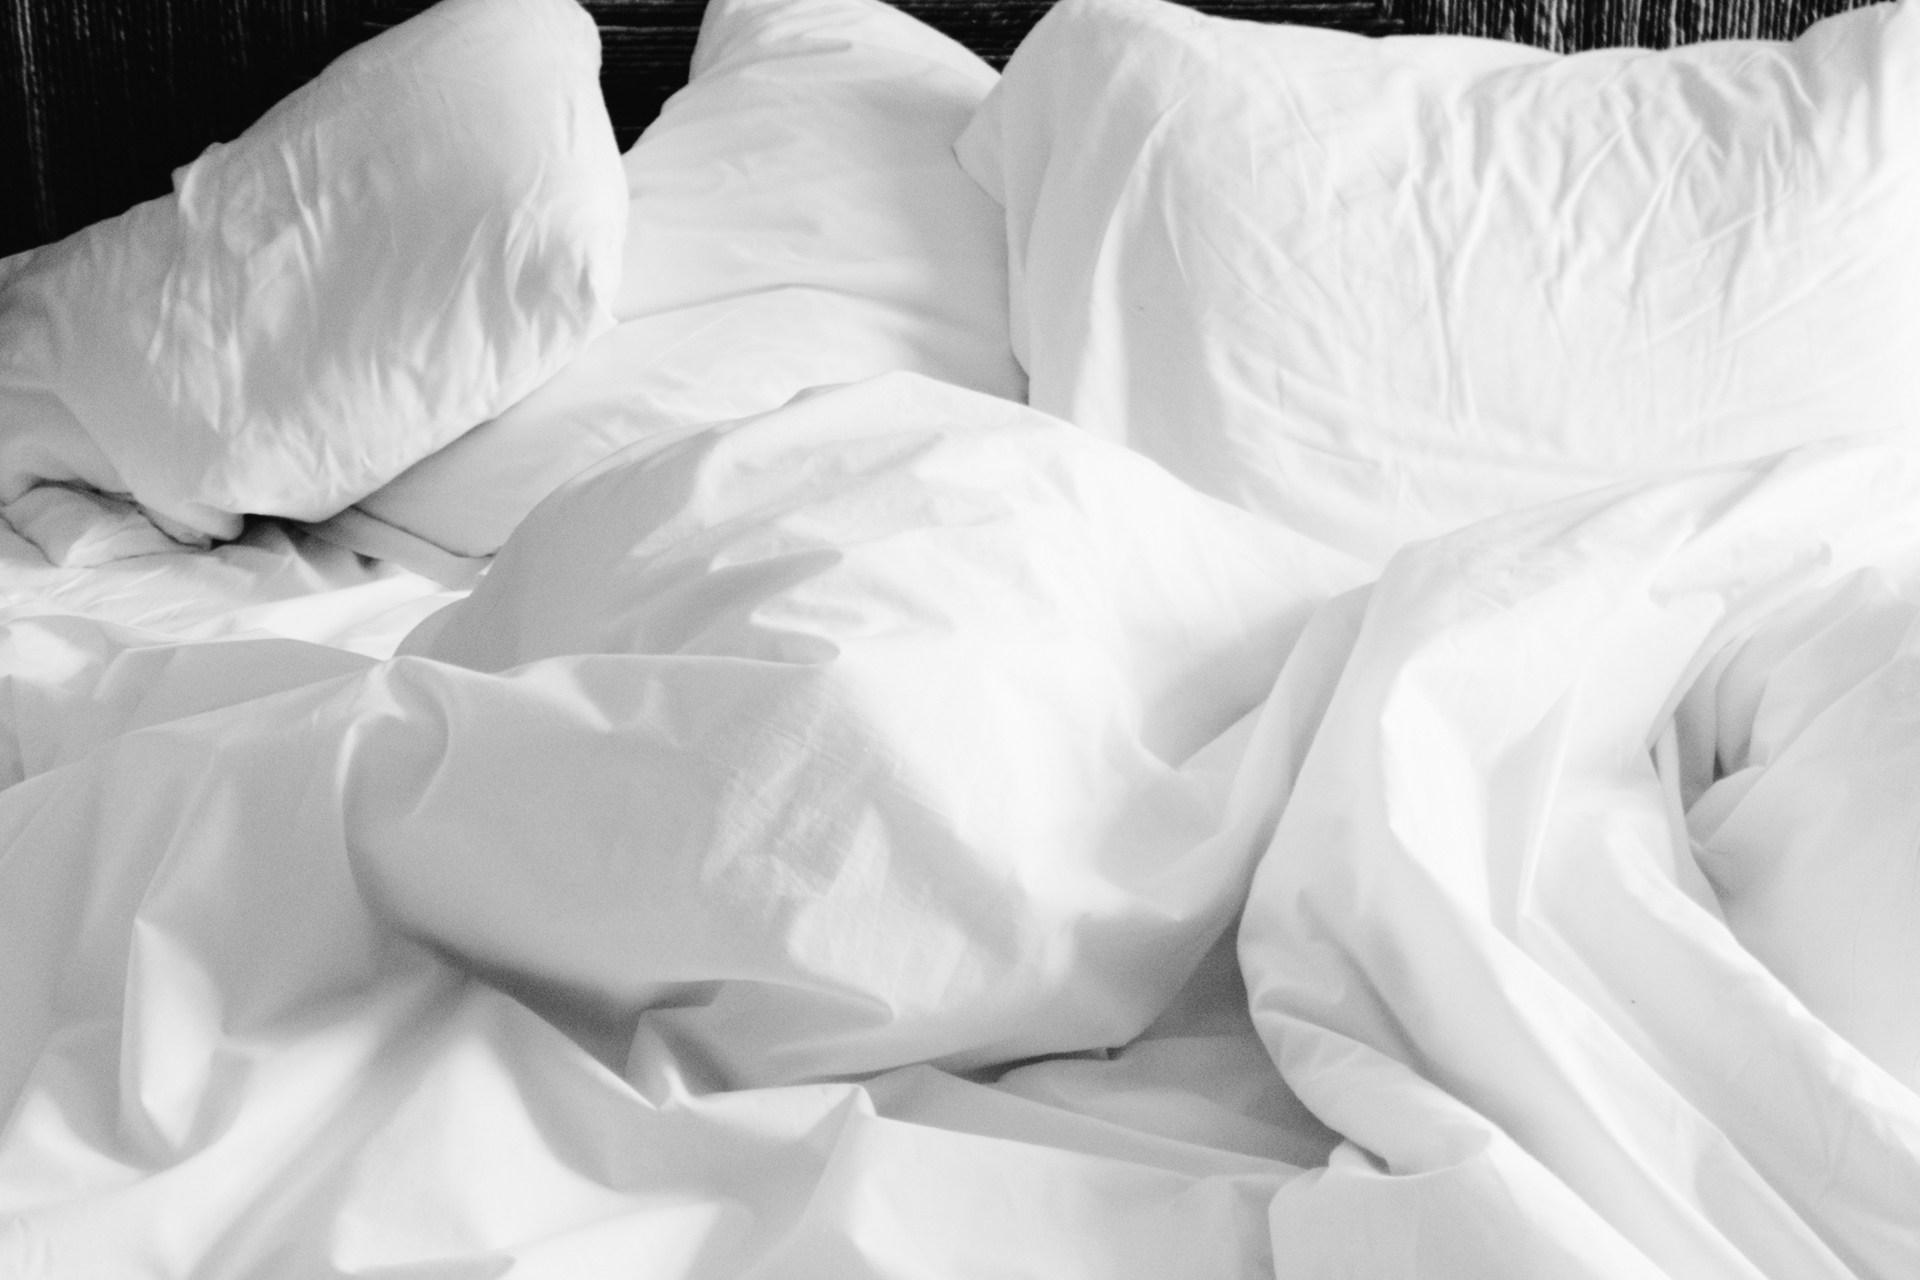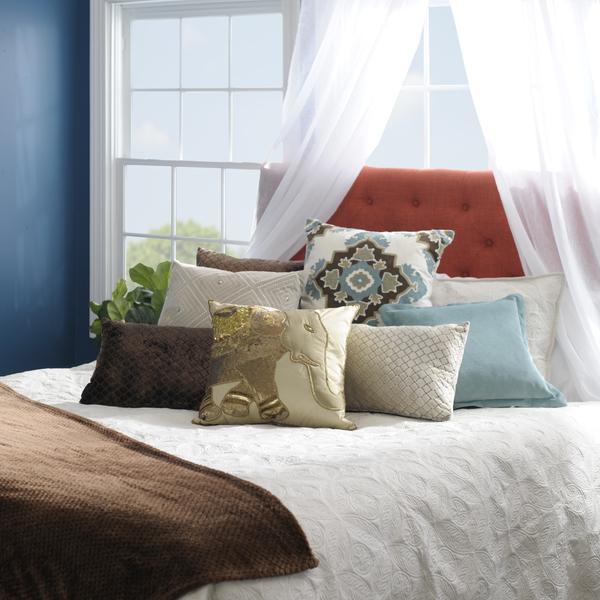The first image is the image on the left, the second image is the image on the right. Examine the images to the left and right. Is the description "An image shows a bed that features a round design element." accurate? Answer yes or no. No. The first image is the image on the left, the second image is the image on the right. Given the left and right images, does the statement "Several throw pillows sit on a bed in at least one of the images." hold true? Answer yes or no. Yes. 